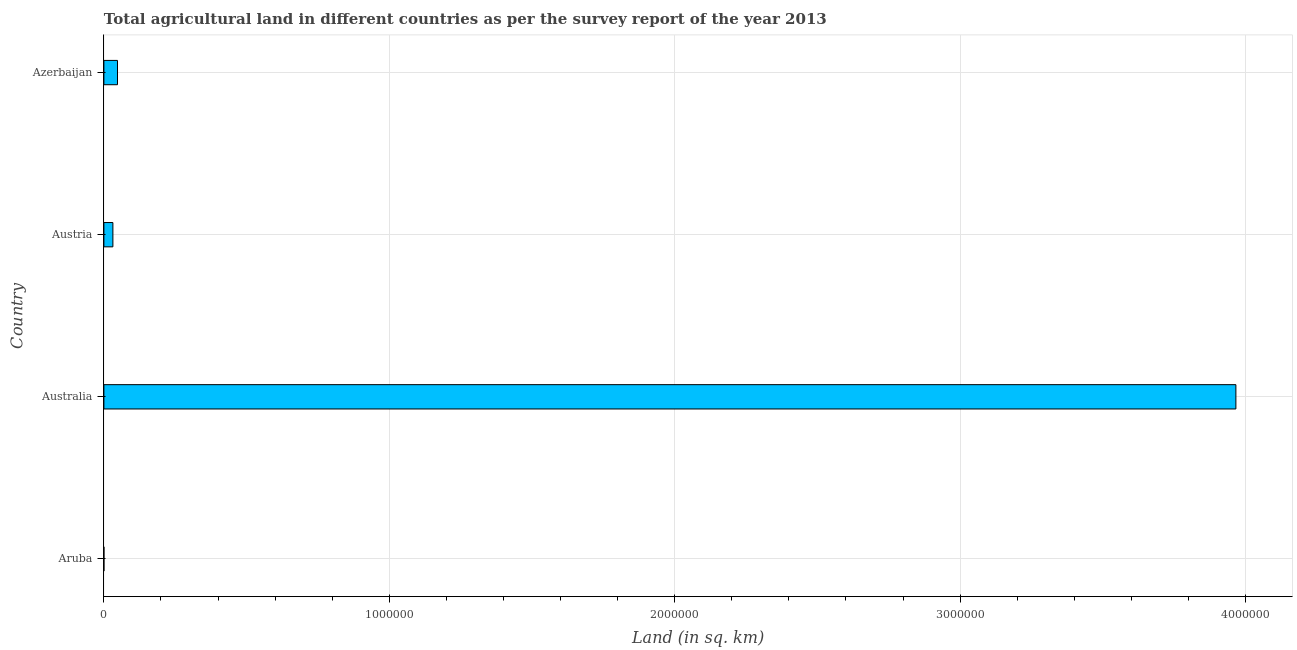Does the graph contain any zero values?
Your answer should be very brief. No. Does the graph contain grids?
Provide a succinct answer. Yes. What is the title of the graph?
Your answer should be very brief. Total agricultural land in different countries as per the survey report of the year 2013. What is the label or title of the X-axis?
Make the answer very short. Land (in sq. km). Across all countries, what is the maximum agricultural land?
Your answer should be very brief. 3.97e+06. Across all countries, what is the minimum agricultural land?
Your response must be concise. 20. In which country was the agricultural land minimum?
Make the answer very short. Aruba. What is the sum of the agricultural land?
Make the answer very short. 4.05e+06. What is the difference between the agricultural land in Aruba and Azerbaijan?
Ensure brevity in your answer.  -4.77e+04. What is the average agricultural land per country?
Your answer should be very brief. 1.01e+06. What is the median agricultural land?
Make the answer very short. 3.96e+04. What is the difference between the highest and the second highest agricultural land?
Give a very brief answer. 3.92e+06. What is the difference between the highest and the lowest agricultural land?
Provide a short and direct response. 3.97e+06. In how many countries, is the agricultural land greater than the average agricultural land taken over all countries?
Ensure brevity in your answer.  1. How many bars are there?
Make the answer very short. 4. How many countries are there in the graph?
Your answer should be compact. 4. What is the Land (in sq. km) of Aruba?
Give a very brief answer. 20. What is the Land (in sq. km) in Australia?
Offer a very short reply. 3.97e+06. What is the Land (in sq. km) of Austria?
Make the answer very short. 3.15e+04. What is the Land (in sq. km) of Azerbaijan?
Offer a very short reply. 4.77e+04. What is the difference between the Land (in sq. km) in Aruba and Australia?
Your answer should be very brief. -3.97e+06. What is the difference between the Land (in sq. km) in Aruba and Austria?
Your answer should be compact. -3.15e+04. What is the difference between the Land (in sq. km) in Aruba and Azerbaijan?
Ensure brevity in your answer.  -4.77e+04. What is the difference between the Land (in sq. km) in Australia and Austria?
Keep it short and to the point. 3.93e+06. What is the difference between the Land (in sq. km) in Australia and Azerbaijan?
Provide a succinct answer. 3.92e+06. What is the difference between the Land (in sq. km) in Austria and Azerbaijan?
Offer a very short reply. -1.62e+04. What is the ratio of the Land (in sq. km) in Aruba to that in Austria?
Keep it short and to the point. 0. What is the ratio of the Land (in sq. km) in Australia to that in Austria?
Provide a succinct answer. 125.73. What is the ratio of the Land (in sq. km) in Australia to that in Azerbaijan?
Ensure brevity in your answer.  83.15. What is the ratio of the Land (in sq. km) in Austria to that in Azerbaijan?
Offer a terse response. 0.66. 